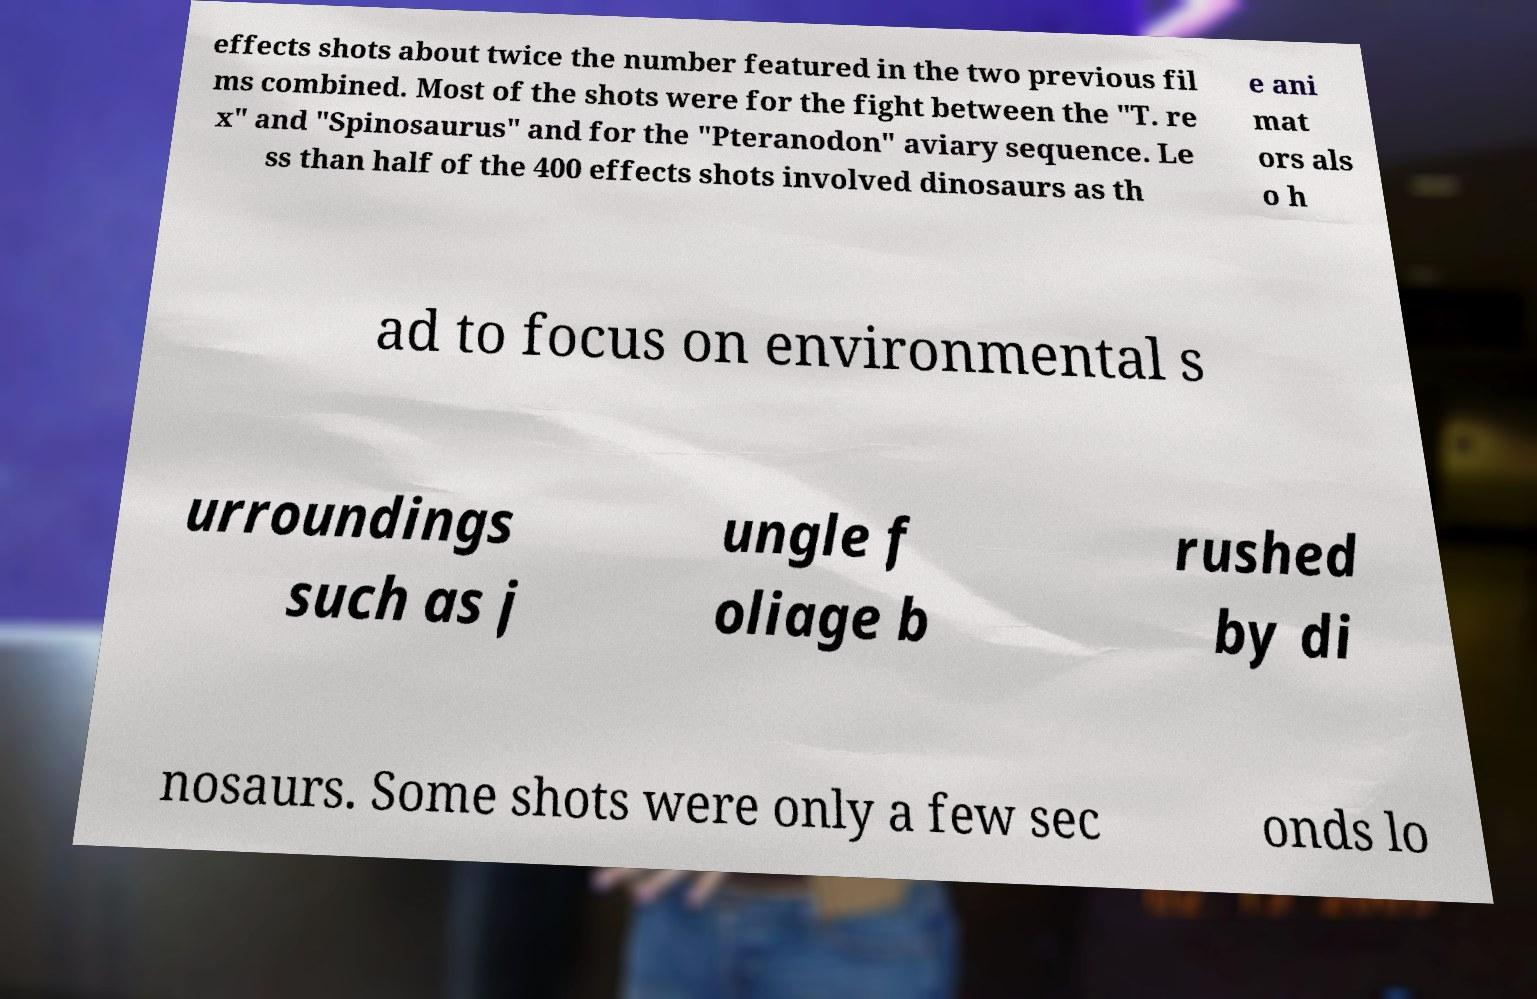I need the written content from this picture converted into text. Can you do that? effects shots about twice the number featured in the two previous fil ms combined. Most of the shots were for the fight between the "T. re x" and "Spinosaurus" and for the "Pteranodon" aviary sequence. Le ss than half of the 400 effects shots involved dinosaurs as th e ani mat ors als o h ad to focus on environmental s urroundings such as j ungle f oliage b rushed by di nosaurs. Some shots were only a few sec onds lo 